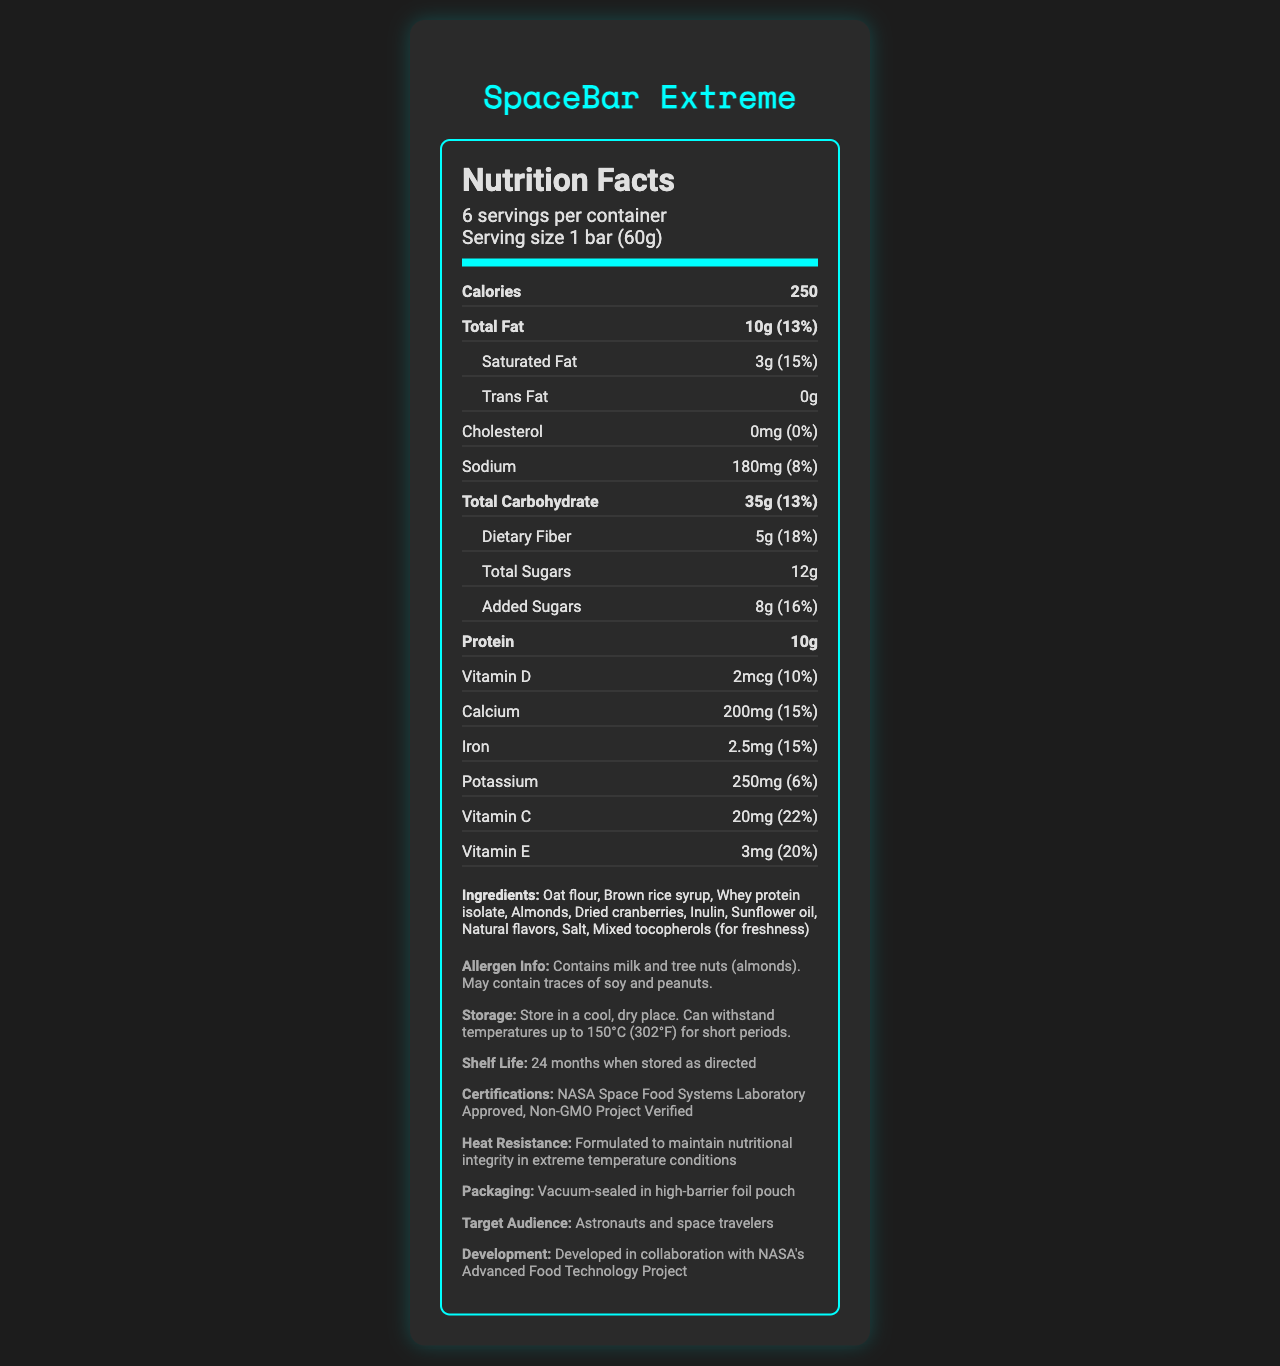what is the serving size of the SpaceBar Extreme? The serving size is mentioned right under the product name in the Nutrition Facts.
Answer: 1 bar (60g) how many calories are in one serving of SpaceBar Extreme? The calorie count for one serving is listed right under the header "Calories."
Answer: 250 what is the total carbohydrate content in one serving? The total carbohydrate content is explicitly mentioned in the Nutrition Facts under the "Total Carbohydrate" section.
Answer: 35g (13%) how much protein does one serving of SpaceBar Extreme contain? The amount of protein is specified in the Nutrition Facts under the "Protein" section.
Answer: 10g what are the main ingredients in the SpaceBar Extreme? The ingredients are listed in the Nutrition Facts under the "Ingredients" section.
Answer: Oat flour, Brown rice syrup, Whey protein isolate, Almonds, Dried cranberries, Inulin, Sunflower oil, Natural flavors, Salt, Mixed tocopherols (for freshness) which vitamins are included in the SpaceBar Extreme? A. Vitamin A, Vitamin B, Vitamin D B. Vitamin C, Vitamin D, Vitamin E C. Vitamin A, Vitamin C, Vitamin E, Vitamin D The listed vitamins in the Nutrition Facts are Vitamin C, Vitamin D, and Vitamin E.
Answer: B what is the serving size of one bar in grams? A. 40g B. 50g C. 60g D. 70g The serving size is specifically mentioned as "1 bar (60g)" under the serving info.
Answer: C how many serving per container are there? A. 4 B. 5 C. 6 D. 7 It is mentioned directly under the servings per container section.
Answer: C does the SpaceBar Extreme contain any trans fat? The Nutrition Facts mention "Trans Fat 0g," indicating there is no trans fat.
Answer: No is the SpaceBar Extreme suitable for people with peanut allergies? The allergen information indicates that it contains milk and tree nuts (almonds) and may contain traces of soy and peanuts.
Answer: No how should the SpaceBar Extreme be stored? The storage instructions are provided in the additional information section.
Answer: Store in a cool, dry place. Can withstand temperatures up to 150°C (302°F) for short periods. what certifications does the SpaceBar Extreme have? The certifications are mentioned at the bottom of the Nutrition Facts label.
Answer: NASA Space Food Systems Laboratory Approved, Non-GMO Project Verified what is the shelf life of the SpaceBar Extreme? The shelf life is listed in the additional information section.
Answer: 24 months when stored as directed describe the main idea of this document. This document offers comprehensive information on the nutritional content, ingredients, and specific characteristics designed for space applications.
Answer: The document provides the Nutrition Facts label for a heat-stable energy bar called SpaceBar Extreme, which is formulated for space travel. It includes detailed nutritional information, ingredients, allergen info, storage instructions, and certifications. what is the daily value percentage of iron in one serving? The daily value percentage for iron is explicitly mentioned under the "Iron" section.
Answer: 15% who is the SpaceBar Extreme targeted at? The target audience for the product is specified in the additional information section.
Answer: Astronauts and space travelers what is the heat resistance claim made about the SpaceBar Extreme? The heat resistance claim can be found in the additional information section.
Answer: Formulated to maintain nutritional integrity in extreme temperature conditions what level of Vitamin D does the SpaceBar Extreme provide? The amount of Vitamin D is listed in the Nutrition Facts under the "Vitamin D" section.
Answer: 2mcg (10%) how is the SpaceBar Extreme packaged? The packaging description can be found in the additional information section.
Answer: Vacuum-sealed in a high-barrier foil pouch what is the production batch number of this product? The document does not provide any details regarding the production batch number.
Answer: Not enough information 